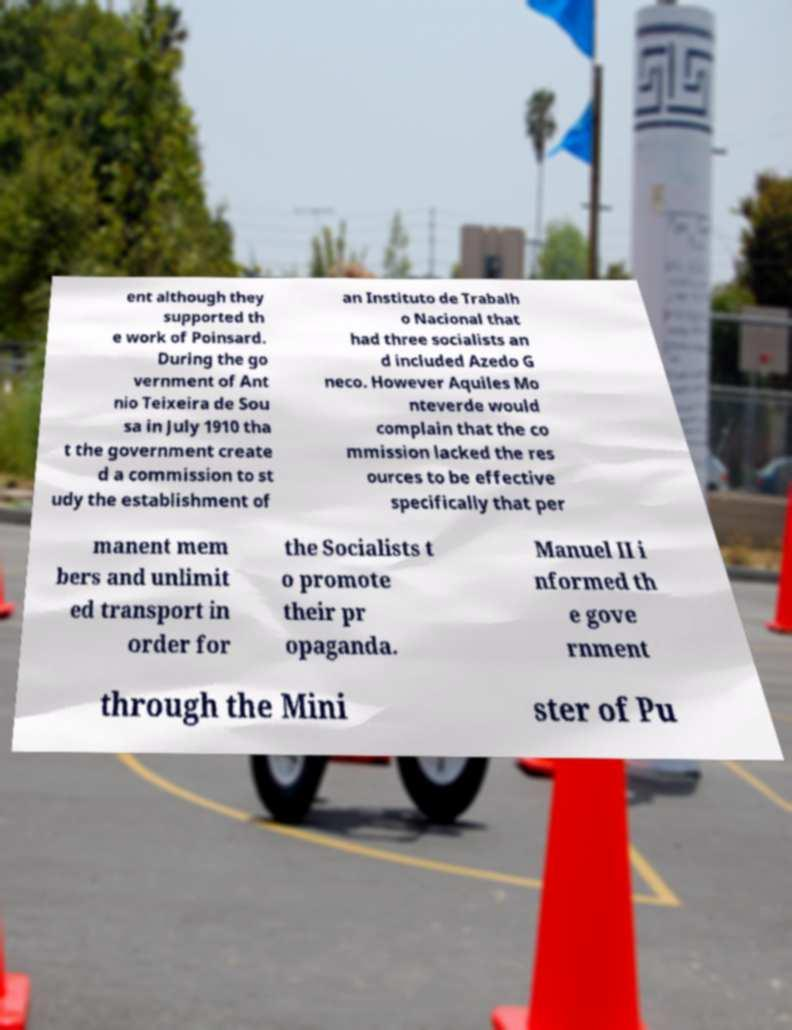What messages or text are displayed in this image? I need them in a readable, typed format. ent although they supported th e work of Poinsard. During the go vernment of Ant nio Teixeira de Sou sa in July 1910 tha t the government create d a commission to st udy the establishment of an Instituto de Trabalh o Nacional that had three socialists an d included Azedo G neco. However Aquiles Mo nteverde would complain that the co mmission lacked the res ources to be effective specifically that per manent mem bers and unlimit ed transport in order for the Socialists t o promote their pr opaganda. Manuel II i nformed th e gove rnment through the Mini ster of Pu 